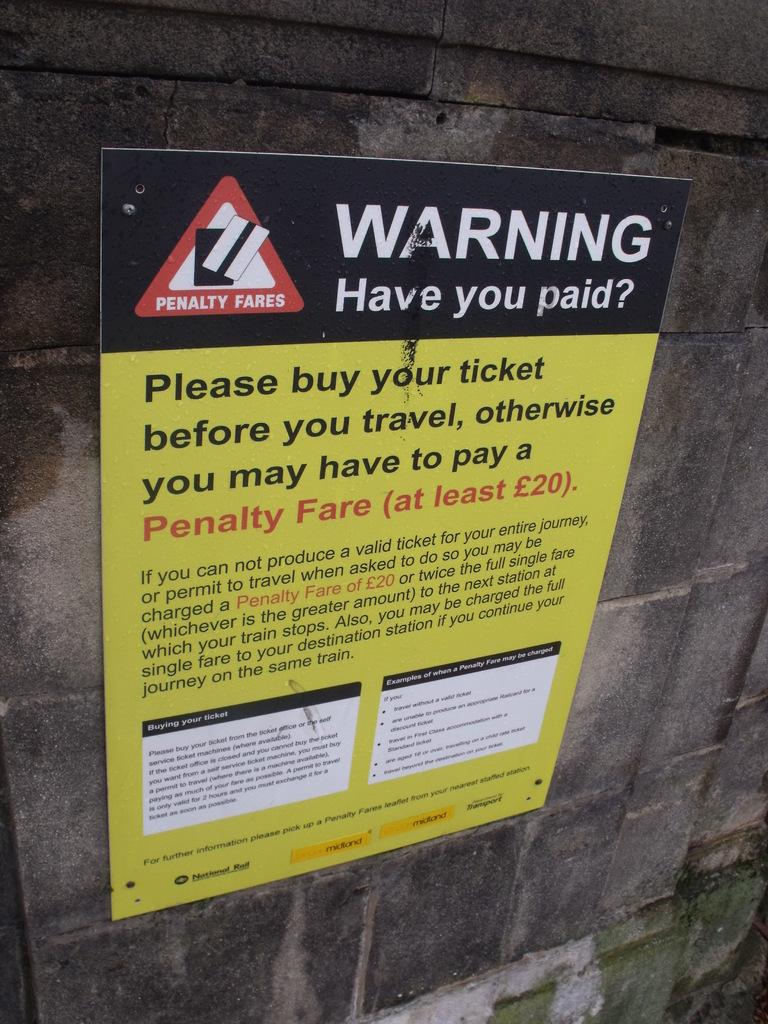Provide a one-sentence caption for the provided image. A sign warns that there's a penalty fare for failing to buy your ticket before you travel. 